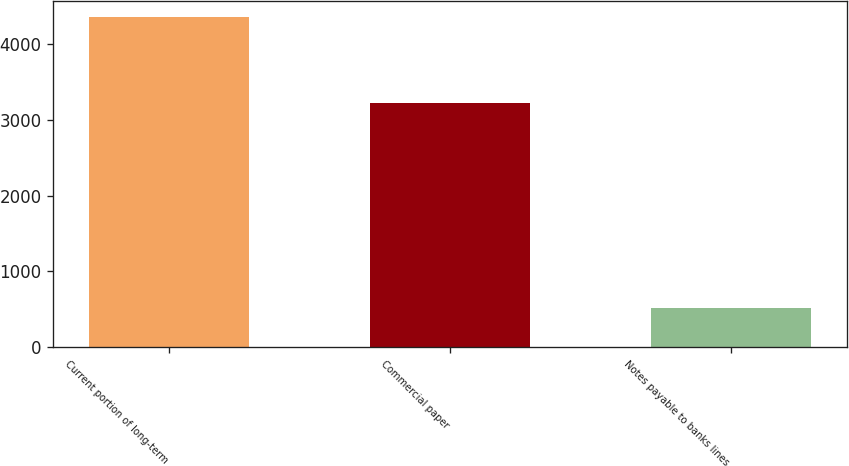<chart> <loc_0><loc_0><loc_500><loc_500><bar_chart><fcel>Current portion of long-term<fcel>Commercial paper<fcel>Notes payable to banks lines<nl><fcel>4345<fcel>3215<fcel>523<nl></chart> 